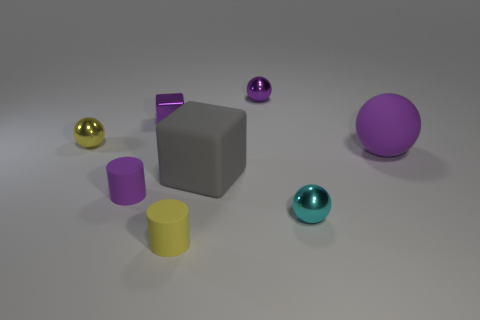Add 1 big rubber blocks. How many objects exist? 9 Subtract all cyan balls. How many balls are left? 3 Subtract all metal spheres. How many spheres are left? 1 Subtract all cylinders. How many objects are left? 6 Subtract 1 cylinders. How many cylinders are left? 1 Subtract all cyan spheres. How many gray cylinders are left? 0 Add 4 tiny shiny objects. How many tiny shiny objects are left? 8 Add 4 small cyan rubber cubes. How many small cyan rubber cubes exist? 4 Subtract 1 yellow balls. How many objects are left? 7 Subtract all purple cylinders. Subtract all yellow balls. How many cylinders are left? 1 